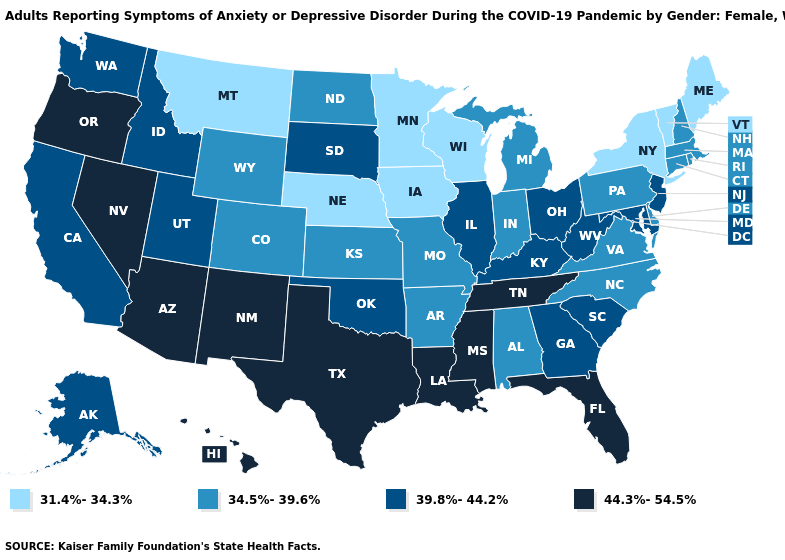Name the states that have a value in the range 39.8%-44.2%?
Concise answer only. Alaska, California, Georgia, Idaho, Illinois, Kentucky, Maryland, New Jersey, Ohio, Oklahoma, South Carolina, South Dakota, Utah, Washington, West Virginia. Among the states that border North Carolina , which have the lowest value?
Write a very short answer. Virginia. Name the states that have a value in the range 44.3%-54.5%?
Answer briefly. Arizona, Florida, Hawaii, Louisiana, Mississippi, Nevada, New Mexico, Oregon, Tennessee, Texas. Which states have the lowest value in the West?
Quick response, please. Montana. Name the states that have a value in the range 44.3%-54.5%?
Be succinct. Arizona, Florida, Hawaii, Louisiana, Mississippi, Nevada, New Mexico, Oregon, Tennessee, Texas. Does New Mexico have the lowest value in the USA?
Keep it brief. No. Does the first symbol in the legend represent the smallest category?
Keep it brief. Yes. What is the value of Louisiana?
Write a very short answer. 44.3%-54.5%. What is the value of Florida?
Quick response, please. 44.3%-54.5%. Which states have the lowest value in the West?
Give a very brief answer. Montana. What is the highest value in the West ?
Answer briefly. 44.3%-54.5%. What is the highest value in the Northeast ?
Concise answer only. 39.8%-44.2%. How many symbols are there in the legend?
Write a very short answer. 4. What is the lowest value in states that border New Jersey?
Keep it brief. 31.4%-34.3%. 